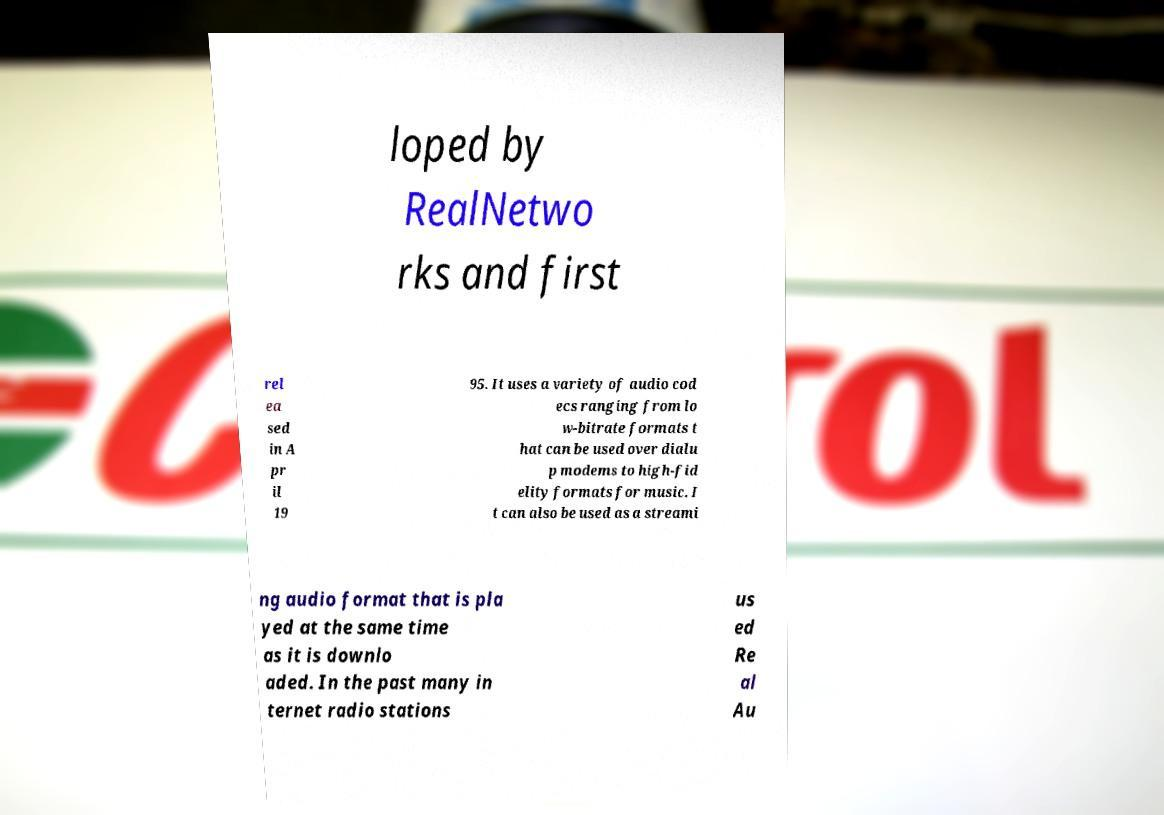Please identify and transcribe the text found in this image. loped by RealNetwo rks and first rel ea sed in A pr il 19 95. It uses a variety of audio cod ecs ranging from lo w-bitrate formats t hat can be used over dialu p modems to high-fid elity formats for music. I t can also be used as a streami ng audio format that is pla yed at the same time as it is downlo aded. In the past many in ternet radio stations us ed Re al Au 